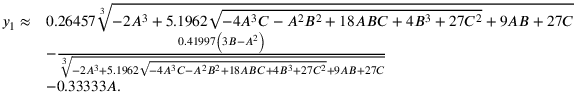<formula> <loc_0><loc_0><loc_500><loc_500>\begin{array} { r l } { y _ { 1 } \approx } & { 0 . 2 6 4 5 7 \sqrt { [ } 3 ] { - 2 A ^ { 3 } + 5 . 1 9 6 2 \sqrt { - 4 A ^ { 3 } C - A ^ { 2 } B ^ { 2 } + 1 8 A B C + 4 B ^ { 3 } + 2 7 C ^ { 2 } } + 9 A B + 2 7 C } } \\ & { - \frac { 0 . 4 1 9 9 7 \left ( 3 B - A ^ { 2 } \right ) } { \sqrt { [ } 3 ] { - 2 A ^ { 3 } + 5 . 1 9 6 2 \sqrt { - 4 A ^ { 3 } C - A ^ { 2 } B ^ { 2 } + 1 8 A B C + 4 B ^ { 3 } + 2 7 C ^ { 2 } } + 9 A B + 2 7 C } } } \\ & { - 0 . 3 3 3 3 3 A . } \end{array}</formula> 